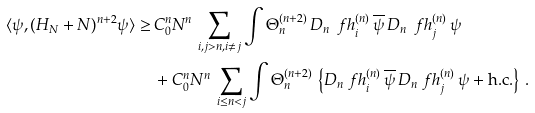Convert formula to latex. <formula><loc_0><loc_0><loc_500><loc_500>\langle \psi , ( H _ { N } + N ) ^ { n + 2 } \psi \rangle \geq \, & C _ { 0 } ^ { n } N ^ { n } \, \sum _ { i , j > n , i \neq j } \int \Theta ^ { ( n + 2 ) } _ { n } \, D _ { n } \, \ f h ^ { ( n ) } _ { i } \, \overline { \psi } \, D _ { n } \, \ f h ^ { ( n ) } _ { j } \, \psi \\ & + C _ { 0 } ^ { n } N ^ { n } \, \sum _ { i \leq n < j } \int \Theta ^ { ( n + 2 ) } _ { n } \, \left \{ D _ { n } \ f h ^ { ( n ) } _ { i } \, \overline { \psi } \, D _ { n } \ f h ^ { ( n ) } _ { j } \, \psi + \text {h.c.} \right \} \, .</formula> 